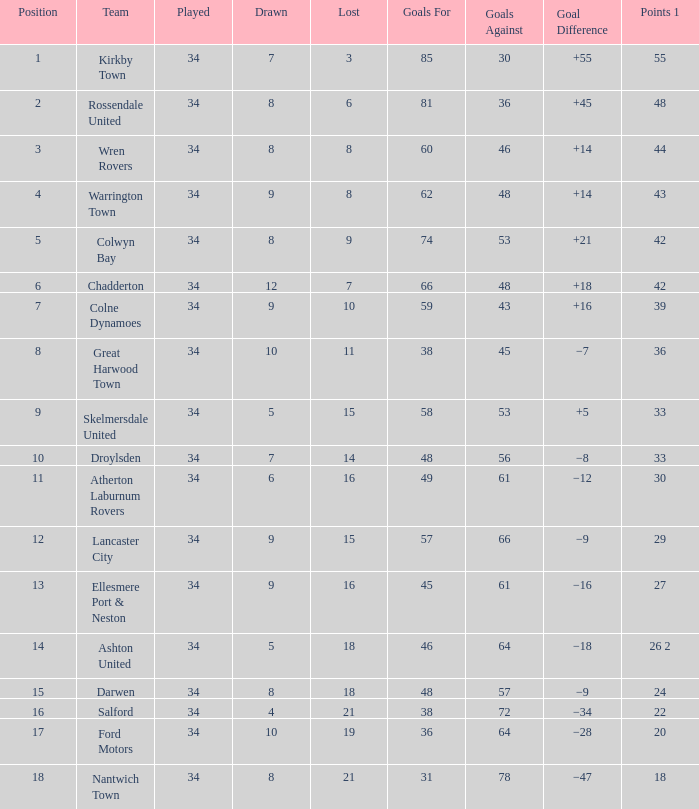What is the total number of goals for when the drawn is less than 7, less than 21 games have been lost, and there are 1 of 33 points? 1.0. 